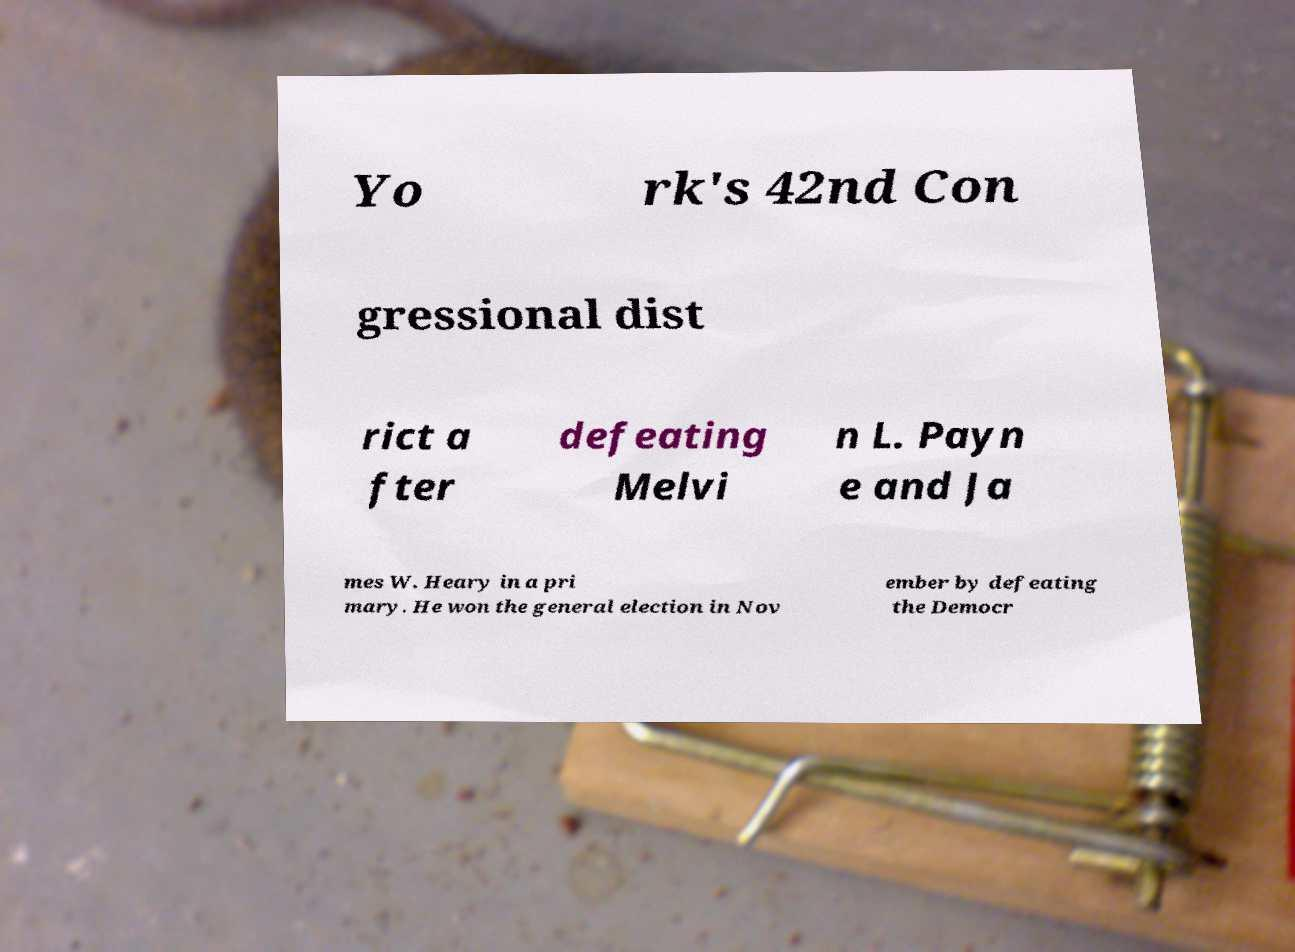Please read and relay the text visible in this image. What does it say? Yo rk's 42nd Con gressional dist rict a fter defeating Melvi n L. Payn e and Ja mes W. Heary in a pri mary. He won the general election in Nov ember by defeating the Democr 